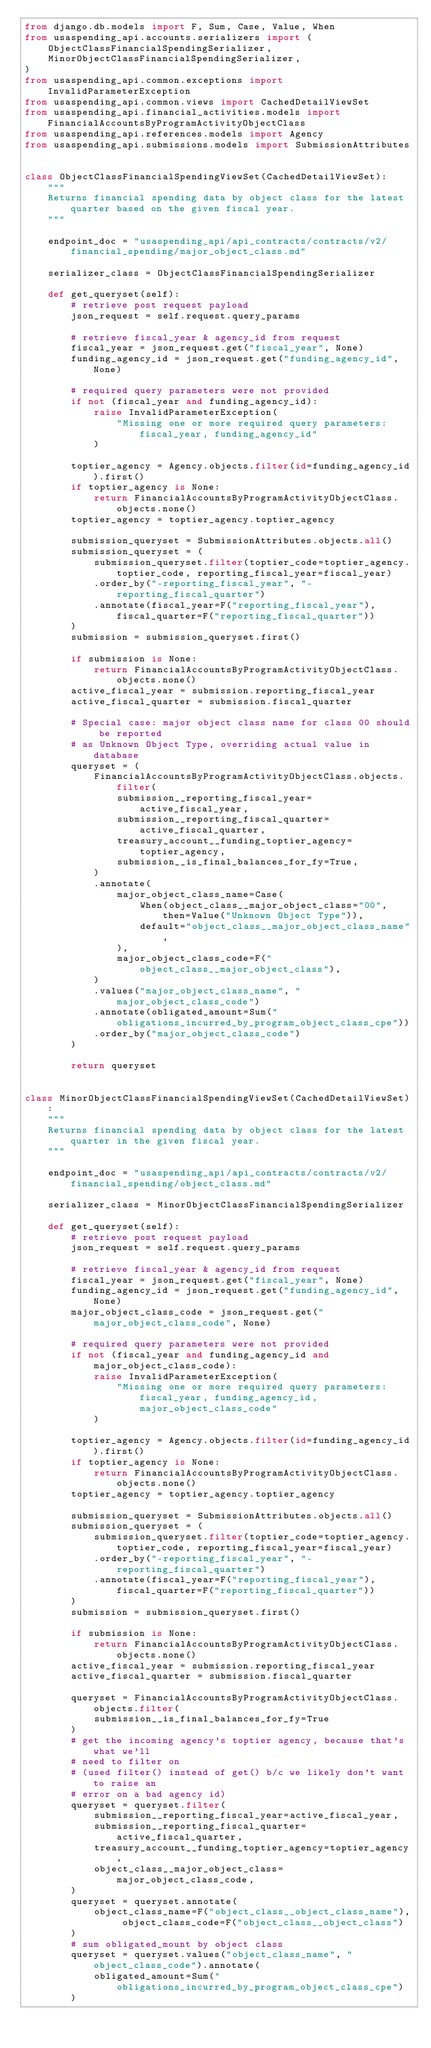<code> <loc_0><loc_0><loc_500><loc_500><_Python_>from django.db.models import F, Sum, Case, Value, When
from usaspending_api.accounts.serializers import (
    ObjectClassFinancialSpendingSerializer,
    MinorObjectClassFinancialSpendingSerializer,
)
from usaspending_api.common.exceptions import InvalidParameterException
from usaspending_api.common.views import CachedDetailViewSet
from usaspending_api.financial_activities.models import FinancialAccountsByProgramActivityObjectClass
from usaspending_api.references.models import Agency
from usaspending_api.submissions.models import SubmissionAttributes


class ObjectClassFinancialSpendingViewSet(CachedDetailViewSet):
    """
    Returns financial spending data by object class for the latest quarter based on the given fiscal year.
    """

    endpoint_doc = "usaspending_api/api_contracts/contracts/v2/financial_spending/major_object_class.md"

    serializer_class = ObjectClassFinancialSpendingSerializer

    def get_queryset(self):
        # retrieve post request payload
        json_request = self.request.query_params

        # retrieve fiscal_year & agency_id from request
        fiscal_year = json_request.get("fiscal_year", None)
        funding_agency_id = json_request.get("funding_agency_id", None)

        # required query parameters were not provided
        if not (fiscal_year and funding_agency_id):
            raise InvalidParameterException(
                "Missing one or more required query parameters: fiscal_year, funding_agency_id"
            )

        toptier_agency = Agency.objects.filter(id=funding_agency_id).first()
        if toptier_agency is None:
            return FinancialAccountsByProgramActivityObjectClass.objects.none()
        toptier_agency = toptier_agency.toptier_agency

        submission_queryset = SubmissionAttributes.objects.all()
        submission_queryset = (
            submission_queryset.filter(toptier_code=toptier_agency.toptier_code, reporting_fiscal_year=fiscal_year)
            .order_by("-reporting_fiscal_year", "-reporting_fiscal_quarter")
            .annotate(fiscal_year=F("reporting_fiscal_year"), fiscal_quarter=F("reporting_fiscal_quarter"))
        )
        submission = submission_queryset.first()

        if submission is None:
            return FinancialAccountsByProgramActivityObjectClass.objects.none()
        active_fiscal_year = submission.reporting_fiscal_year
        active_fiscal_quarter = submission.fiscal_quarter

        # Special case: major object class name for class 00 should be reported
        # as Unknown Object Type, overriding actual value in database
        queryset = (
            FinancialAccountsByProgramActivityObjectClass.objects.filter(
                submission__reporting_fiscal_year=active_fiscal_year,
                submission__reporting_fiscal_quarter=active_fiscal_quarter,
                treasury_account__funding_toptier_agency=toptier_agency,
                submission__is_final_balances_for_fy=True,
            )
            .annotate(
                major_object_class_name=Case(
                    When(object_class__major_object_class="00", then=Value("Unknown Object Type")),
                    default="object_class__major_object_class_name",
                ),
                major_object_class_code=F("object_class__major_object_class"),
            )
            .values("major_object_class_name", "major_object_class_code")
            .annotate(obligated_amount=Sum("obligations_incurred_by_program_object_class_cpe"))
            .order_by("major_object_class_code")
        )

        return queryset


class MinorObjectClassFinancialSpendingViewSet(CachedDetailViewSet):
    """
    Returns financial spending data by object class for the latest quarter in the given fiscal year.
    """

    endpoint_doc = "usaspending_api/api_contracts/contracts/v2/financial_spending/object_class.md"

    serializer_class = MinorObjectClassFinancialSpendingSerializer

    def get_queryset(self):
        # retrieve post request payload
        json_request = self.request.query_params

        # retrieve fiscal_year & agency_id from request
        fiscal_year = json_request.get("fiscal_year", None)
        funding_agency_id = json_request.get("funding_agency_id", None)
        major_object_class_code = json_request.get("major_object_class_code", None)

        # required query parameters were not provided
        if not (fiscal_year and funding_agency_id and major_object_class_code):
            raise InvalidParameterException(
                "Missing one or more required query parameters: fiscal_year, funding_agency_id, major_object_class_code"
            )

        toptier_agency = Agency.objects.filter(id=funding_agency_id).first()
        if toptier_agency is None:
            return FinancialAccountsByProgramActivityObjectClass.objects.none()
        toptier_agency = toptier_agency.toptier_agency

        submission_queryset = SubmissionAttributes.objects.all()
        submission_queryset = (
            submission_queryset.filter(toptier_code=toptier_agency.toptier_code, reporting_fiscal_year=fiscal_year)
            .order_by("-reporting_fiscal_year", "-reporting_fiscal_quarter")
            .annotate(fiscal_year=F("reporting_fiscal_year"), fiscal_quarter=F("reporting_fiscal_quarter"))
        )
        submission = submission_queryset.first()

        if submission is None:
            return FinancialAccountsByProgramActivityObjectClass.objects.none()
        active_fiscal_year = submission.reporting_fiscal_year
        active_fiscal_quarter = submission.fiscal_quarter

        queryset = FinancialAccountsByProgramActivityObjectClass.objects.filter(
            submission__is_final_balances_for_fy=True
        )
        # get the incoming agency's toptier agency, because that's what we'll
        # need to filter on
        # (used filter() instead of get() b/c we likely don't want to raise an
        # error on a bad agency id)
        queryset = queryset.filter(
            submission__reporting_fiscal_year=active_fiscal_year,
            submission__reporting_fiscal_quarter=active_fiscal_quarter,
            treasury_account__funding_toptier_agency=toptier_agency,
            object_class__major_object_class=major_object_class_code,
        )
        queryset = queryset.annotate(
            object_class_name=F("object_class__object_class_name"), object_class_code=F("object_class__object_class")
        )
        # sum obligated_mount by object class
        queryset = queryset.values("object_class_name", "object_class_code").annotate(
            obligated_amount=Sum("obligations_incurred_by_program_object_class_cpe")
        )</code> 